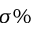Convert formula to latex. <formula><loc_0><loc_0><loc_500><loc_500>\sigma \%</formula> 